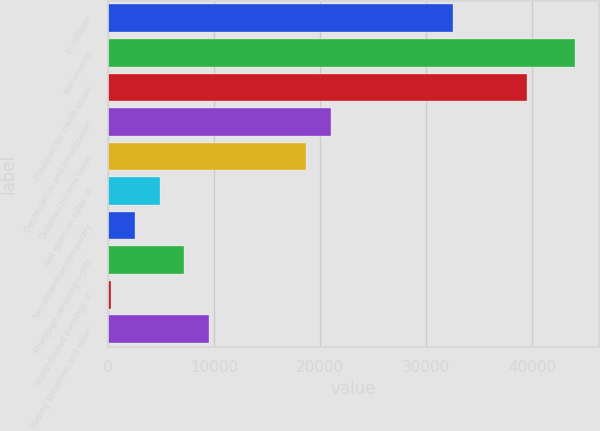<chart> <loc_0><loc_0><loc_500><loc_500><bar_chart><fcel>In millions<fcel>Net income<fcel>Provision for credit losses<fcel>Depreciation and amortization<fcel>Deferred income taxes<fcel>Net gains on sales of<fcel>Net other-than-temporary<fcel>Mortgage servicing rights<fcel>Undistributed earnings of<fcel>Trading securities and other<nl><fcel>32563.8<fcel>44089.8<fcel>39479.4<fcel>21037.8<fcel>18732.6<fcel>4901.4<fcel>2596.2<fcel>7206.6<fcel>291<fcel>9511.8<nl></chart> 